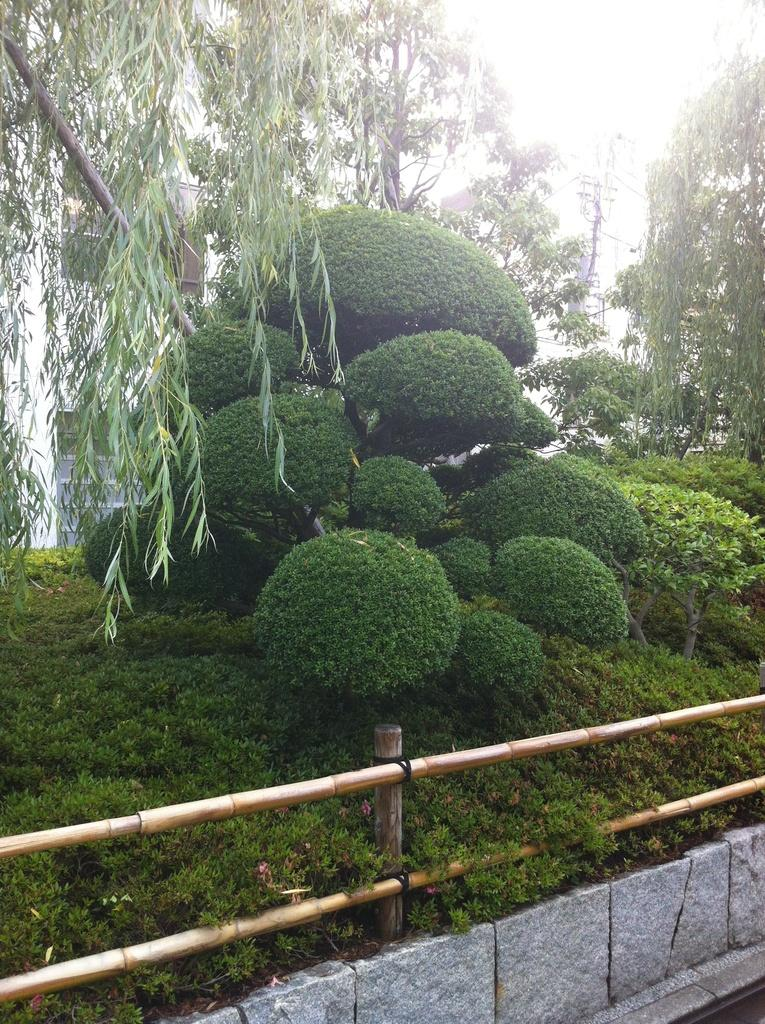What is the main feature that stretches from left to right in the image? There is a fence in the image, stretching from left to right. What type of vegetation can be seen in the image? There are a few plants in the image. What can be seen in the background of the image? There are trees and a building visible in the background of the image. What type of cord is hanging from the tree in the image? There is no cord hanging from the tree in the image; only trees and a building are visible in the background. 